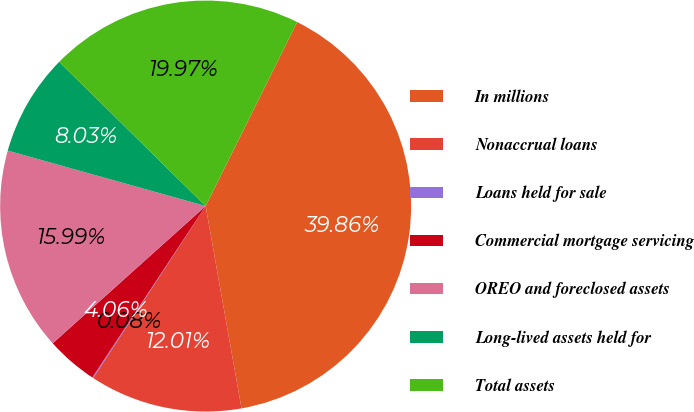Convert chart to OTSL. <chart><loc_0><loc_0><loc_500><loc_500><pie_chart><fcel>In millions<fcel>Nonaccrual loans<fcel>Loans held for sale<fcel>Commercial mortgage servicing<fcel>OREO and foreclosed assets<fcel>Long-lived assets held for<fcel>Total assets<nl><fcel>39.86%<fcel>12.01%<fcel>0.08%<fcel>4.06%<fcel>15.99%<fcel>8.03%<fcel>19.97%<nl></chart> 